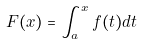Convert formula to latex. <formula><loc_0><loc_0><loc_500><loc_500>F ( x ) = \int _ { a } ^ { x } f ( t ) d t</formula> 